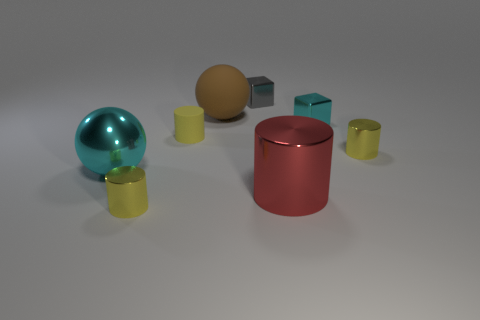What number of other objects are the same shape as the tiny matte object?
Ensure brevity in your answer.  3. There is a big cyan thing in front of the matte ball; does it have the same shape as the tiny yellow thing on the right side of the tiny gray metallic thing?
Offer a very short reply. No. What number of big metal spheres are to the right of the cyan object that is on the left side of the big thing that is behind the tiny cyan object?
Your response must be concise. 0. What color is the metallic sphere?
Ensure brevity in your answer.  Cyan. How many other things are there of the same size as the red cylinder?
Make the answer very short. 2. What material is the other small object that is the same shape as the gray object?
Provide a succinct answer. Metal. The sphere to the left of the yellow metal thing that is on the left side of the tiny yellow cylinder on the right side of the small gray metallic cube is made of what material?
Provide a succinct answer. Metal. The gray cube that is the same material as the big cyan sphere is what size?
Offer a very short reply. Small. Is there any other thing that is the same color as the large matte sphere?
Keep it short and to the point. No. Is the color of the small cylinder in front of the shiny ball the same as the block that is in front of the gray metallic object?
Give a very brief answer. No. 